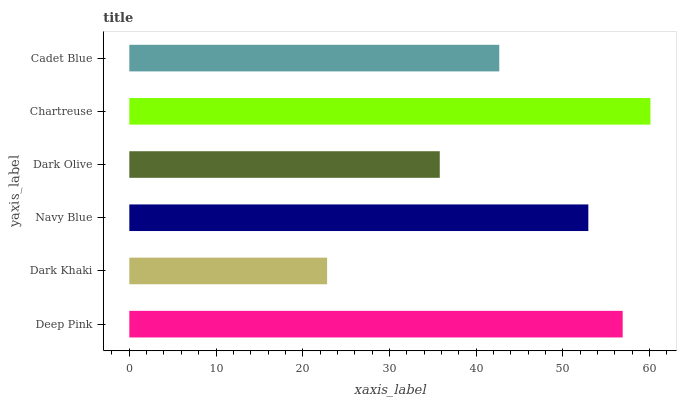Is Dark Khaki the minimum?
Answer yes or no. Yes. Is Chartreuse the maximum?
Answer yes or no. Yes. Is Navy Blue the minimum?
Answer yes or no. No. Is Navy Blue the maximum?
Answer yes or no. No. Is Navy Blue greater than Dark Khaki?
Answer yes or no. Yes. Is Dark Khaki less than Navy Blue?
Answer yes or no. Yes. Is Dark Khaki greater than Navy Blue?
Answer yes or no. No. Is Navy Blue less than Dark Khaki?
Answer yes or no. No. Is Navy Blue the high median?
Answer yes or no. Yes. Is Cadet Blue the low median?
Answer yes or no. Yes. Is Cadet Blue the high median?
Answer yes or no. No. Is Dark Khaki the low median?
Answer yes or no. No. 